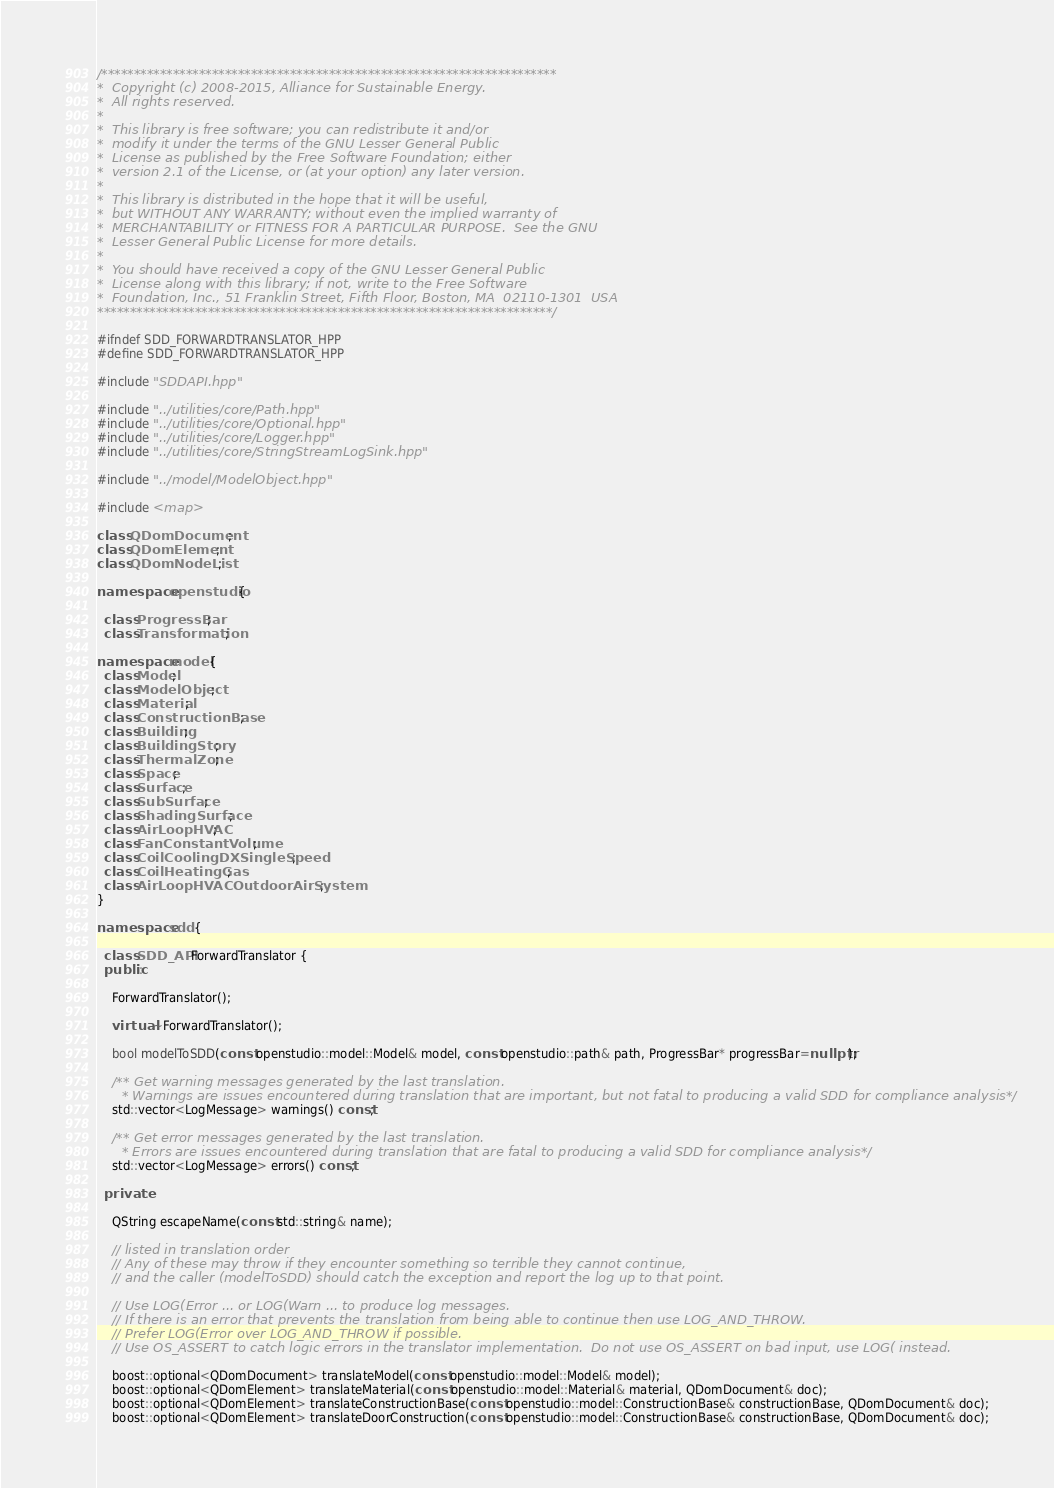<code> <loc_0><loc_0><loc_500><loc_500><_C++_>/**********************************************************************
*  Copyright (c) 2008-2015, Alliance for Sustainable Energy.
*  All rights reserved.
*
*  This library is free software; you can redistribute it and/or
*  modify it under the terms of the GNU Lesser General Public
*  License as published by the Free Software Foundation; either
*  version 2.1 of the License, or (at your option) any later version.
*
*  This library is distributed in the hope that it will be useful,
*  but WITHOUT ANY WARRANTY; without even the implied warranty of
*  MERCHANTABILITY or FITNESS FOR A PARTICULAR PURPOSE.  See the GNU
*  Lesser General Public License for more details.
*
*  You should have received a copy of the GNU Lesser General Public
*  License along with this library; if not, write to the Free Software
*  Foundation, Inc., 51 Franklin Street, Fifth Floor, Boston, MA  02110-1301  USA
**********************************************************************/

#ifndef SDD_FORWARDTRANSLATOR_HPP
#define SDD_FORWARDTRANSLATOR_HPP

#include "SDDAPI.hpp"

#include "../utilities/core/Path.hpp"
#include "../utilities/core/Optional.hpp"
#include "../utilities/core/Logger.hpp"
#include "../utilities/core/StringStreamLogSink.hpp"

#include "../model/ModelObject.hpp"

#include <map>

class QDomDocument;
class QDomElement;
class QDomNodeList;

namespace openstudio {

  class ProgressBar;
  class Transformation;

namespace model {
  class Model;
  class ModelObject;
  class Material;
  class ConstructionBase;
  class Building;
  class BuildingStory;
  class ThermalZone;
  class Space;
  class Surface;
  class SubSurface;
  class ShadingSurface;
  class AirLoopHVAC;
  class FanConstantVolume;
  class CoilCoolingDXSingleSpeed;
  class CoilHeatingGas;
  class AirLoopHVACOutdoorAirSystem;
}

namespace sdd {

  class SDD_API ForwardTranslator {
  public:
    
    ForwardTranslator();

    virtual ~ForwardTranslator();

    bool modelToSDD(const openstudio::model::Model& model, const openstudio::path& path, ProgressBar* progressBar=nullptr);

    /** Get warning messages generated by the last translation.  
      * Warnings are issues encountered during translation that are important, but not fatal to producing a valid SDD for compliance analysis*/
    std::vector<LogMessage> warnings() const;

    /** Get error messages generated by the last translation.
      * Errors are issues encountered during translation that are fatal to producing a valid SDD for compliance analysis*/
    std::vector<LogMessage> errors() const;

  private:

    QString escapeName(const std::string& name);

    // listed in translation order
    // Any of these may throw if they encounter something so terrible they cannot continue,
    // and the caller (modelToSDD) should catch the exception and report the log up to that point.

    // Use LOG(Error ... or LOG(Warn ... to produce log messages.
    // If there is an error that prevents the translation from being able to continue then use LOG_AND_THROW.
    // Prefer LOG(Error over LOG_AND_THROW if possible.
    // Use OS_ASSERT to catch logic errors in the translator implementation.  Do not use OS_ASSERT on bad input, use LOG( instead.

    boost::optional<QDomDocument> translateModel(const openstudio::model::Model& model);
    boost::optional<QDomElement> translateMaterial(const openstudio::model::Material& material, QDomDocument& doc);
    boost::optional<QDomElement> translateConstructionBase(const openstudio::model::ConstructionBase& constructionBase, QDomDocument& doc);
    boost::optional<QDomElement> translateDoorConstruction(const openstudio::model::ConstructionBase& constructionBase, QDomDocument& doc);</code> 